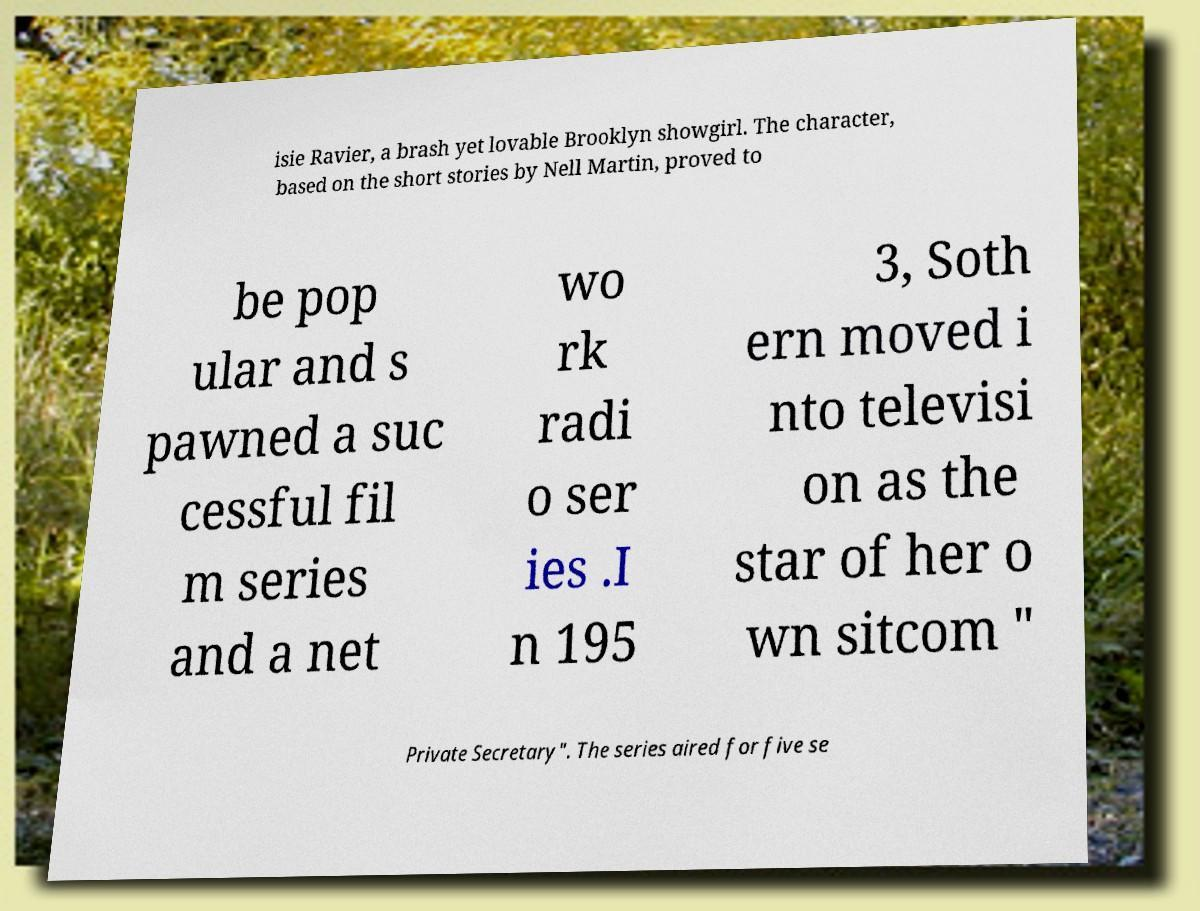Please read and relay the text visible in this image. What does it say? isie Ravier, a brash yet lovable Brooklyn showgirl. The character, based on the short stories by Nell Martin, proved to be pop ular and s pawned a suc cessful fil m series and a net wo rk radi o ser ies .I n 195 3, Soth ern moved i nto televisi on as the star of her o wn sitcom " Private Secretary". The series aired for five se 